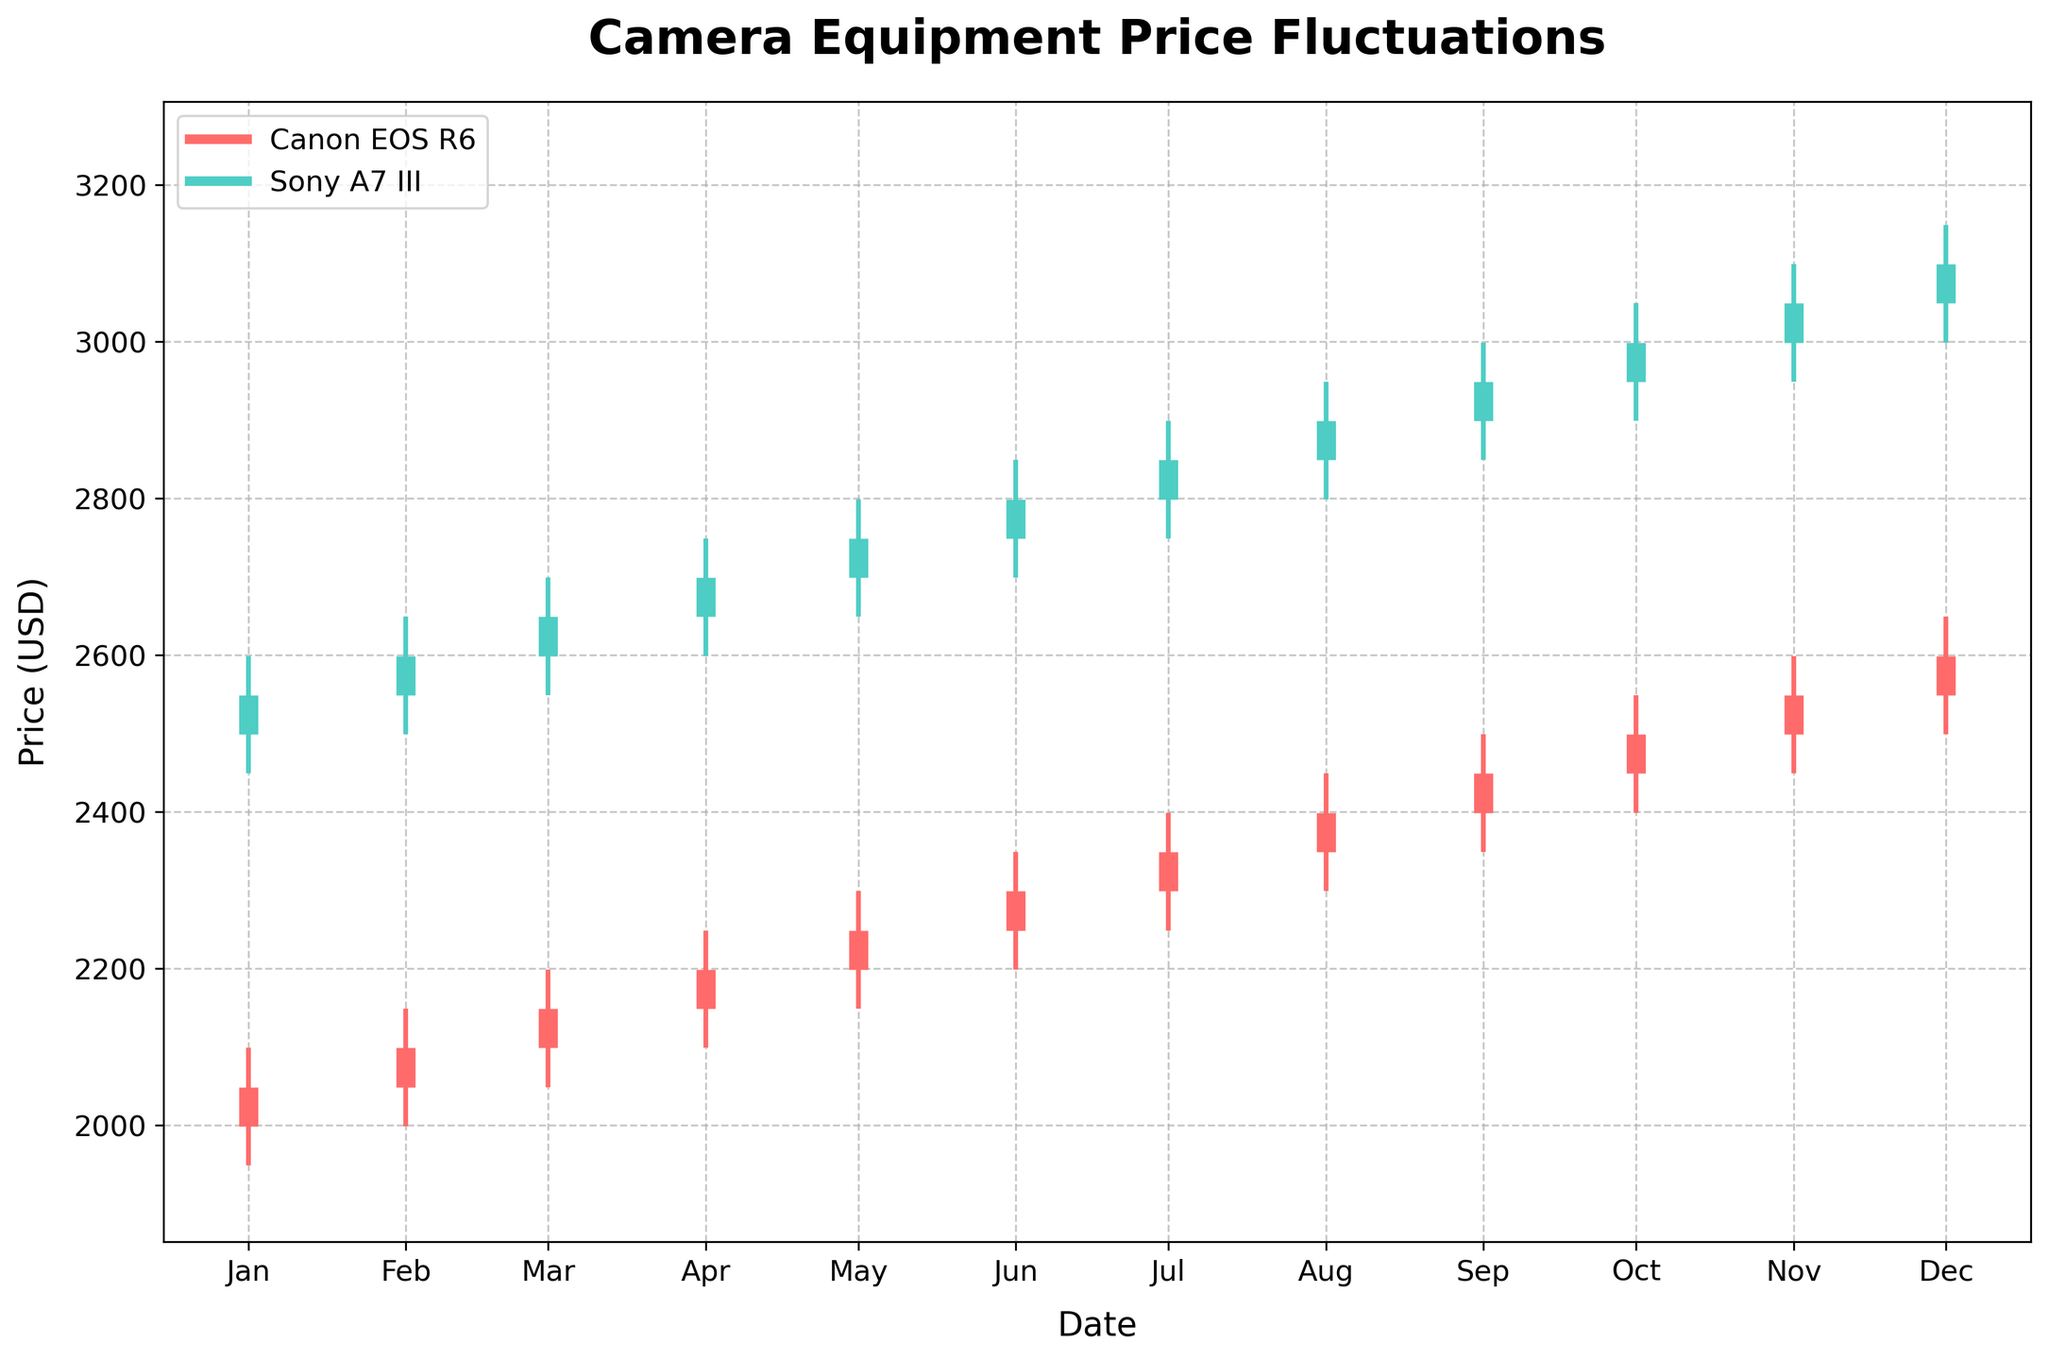What is the title of the chart? The title is located at the top of the chart. It describes the subject of the visualization.
Answer: Camera Equipment Price Fluctuations What is the highest price recorded for the Canon EOS R6 within the year? For the Canon EOS R6, check the highest peak on any of the vertical lines corresponding to the High price within the year. The peak of the highest line represents the maximum price.
Answer: 2649 When did the Sony A7 III reach its highest closing price? Look for the thick horizontal segment representing the closing price of the Sony A7 III series. The highest segment indicates the highest closing price. Cross-reference the date below.
Answer: December How many months does the chart cover? Determine this by counting the number of labeled tick marks along the x-axis, which represents the months.
Answer: 12 Which camera shows a consistent increase in prices throughout the year? Compare the trends of the Canon EOS R6 and Sony A7 III by observing their sequential closing prices (end of the thicker lines). Identify which camera shows a steady increase without any dips.
Answer: Both In which month did the Canon EOS R6 see the largest price increase? Calculate the difference between the closing price of one month and the closing price of the next month for Canon EOS R6. The month with the highest difference shows the largest price increase. This can be visualized by the steepest upward vertical segment between months.
Answer: January to February What is the closing price of the Canon EOS R6 in April? Find the thicker horizontal segment for April corresponding to the Canon EOS R6 series and read off the closing price from the y-axis.
Answer: 2199 How does the price range (High - Low) in April compare between the two cameras? Subtract the Low price from the High price for both cameras for the month of April and compare. Sony A7 III's range is 2749 - 2599, and Canon EOS R6's range is 2249 - 2099. Compare these two values.
Answer: Sony A7 III has a larger range Which month shows the smallest price fluctuation for the Sony A7 III? Find the month where the difference between the High and Low prices (the range of the vertical line segments) is the smallest for the Sony A7 III.
Answer: January What is the general trend of the Sony A7 III price over the year? Observe the direction and progression of the thicker horizontal lines on the chart representing the Sony A7 III over the months.
Answer: Increasing 